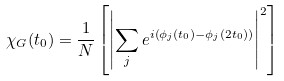Convert formula to latex. <formula><loc_0><loc_0><loc_500><loc_500>\chi _ { G } ( t _ { 0 } ) = \frac { 1 } { N } \left [ \left | \sum _ { j } e ^ { i \left ( \phi _ { j } ( t _ { 0 } ) - \phi _ { j } ( 2 t _ { 0 } ) \right ) } \right | ^ { 2 } \right ]</formula> 